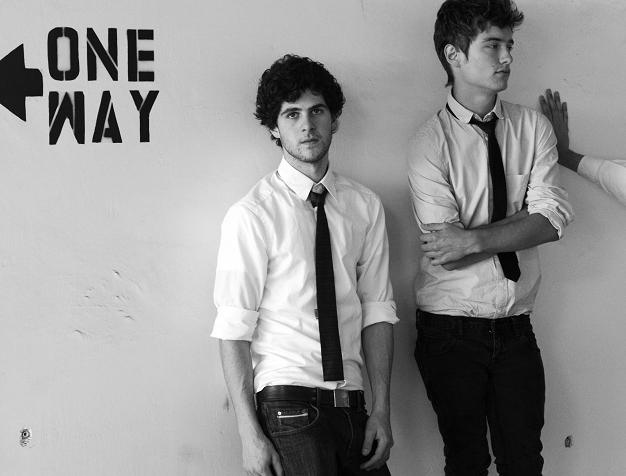Describe the objects in this image and their specific colors. I can see people in lightgray, black, darkgray, and gray tones, people in lightgray, black, darkgray, and gray tones, people in lightgray, darkgray, black, and gray tones, tie in lightgray, black, darkgray, and gray tones, and tie in lightgray, black, gray, and darkgray tones in this image. 